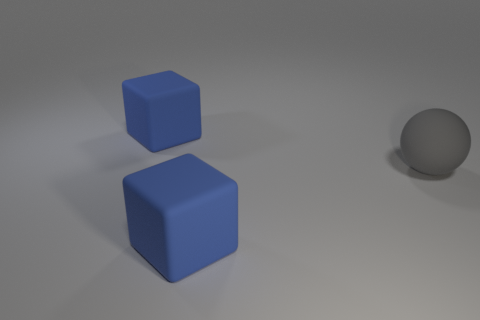Add 2 blue matte cylinders. How many objects exist? 5 Subtract all spheres. How many objects are left? 2 Add 3 large blue matte cubes. How many large blue matte cubes exist? 5 Subtract 1 blue cubes. How many objects are left? 2 Subtract all large objects. Subtract all green shiny cylinders. How many objects are left? 0 Add 3 cubes. How many cubes are left? 5 